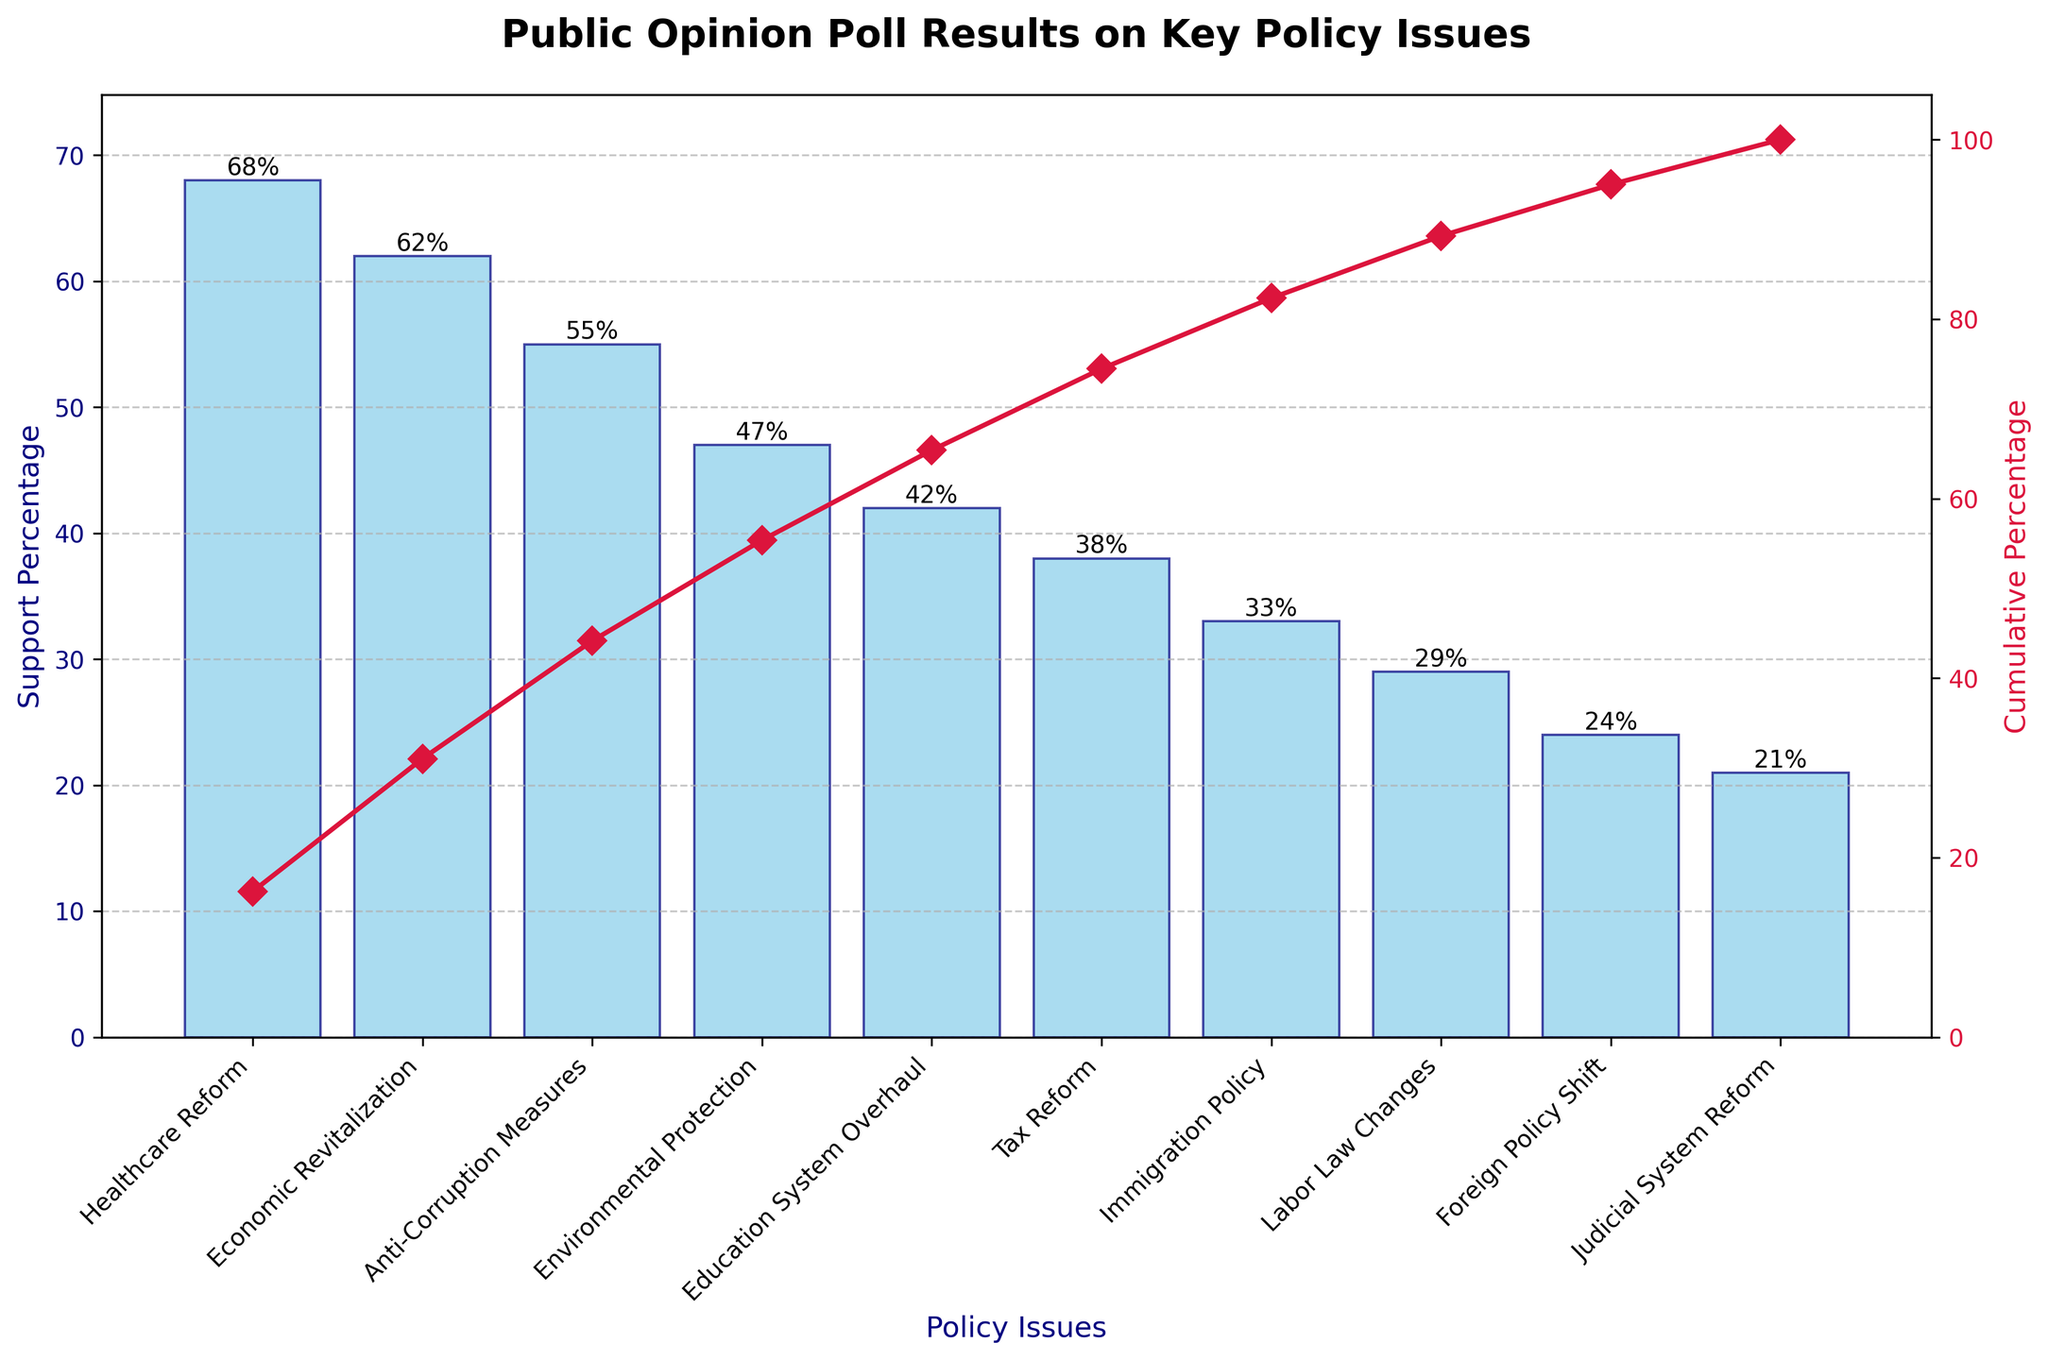What is the title of the chart? The title is usually placed at the top of the chart, and it summarizes what the chart is about. Here, the title "Public Opinion Poll Results on Key Policy Issues" can be observed.
Answer: Public Opinion Poll Results on Key Policy Issues Which policy issue has the highest support percentage? By looking at the tallest bar on the bar plot, we can identify that the policy issue with the highest support percentage is the first one on the x-axis.
Answer: Healthcare Reform 